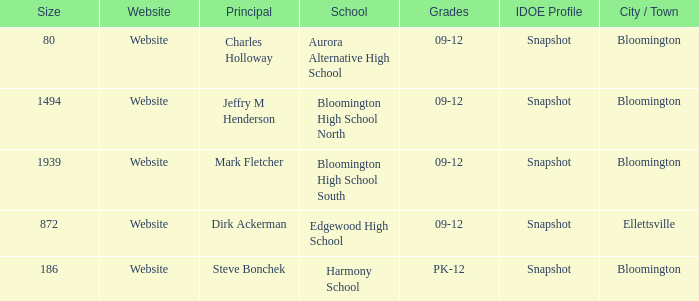Write the full table. {'header': ['Size', 'Website', 'Principal', 'School', 'Grades', 'IDOE Profile', 'City / Town'], 'rows': [['80', 'Website', 'Charles Holloway', 'Aurora Alternative High School', '09-12', 'Snapshot', 'Bloomington'], ['1494', 'Website', 'Jeffry M Henderson', 'Bloomington High School North', '09-12', 'Snapshot', 'Bloomington'], ['1939', 'Website', 'Mark Fletcher', 'Bloomington High School South', '09-12', 'Snapshot', 'Bloomington'], ['872', 'Website', 'Dirk Ackerman', 'Edgewood High School', '09-12', 'Snapshot', 'Ellettsville'], ['186', 'Website', 'Steve Bonchek', 'Harmony School', 'PK-12', 'Snapshot', 'Bloomington']]} Who's the principal of Edgewood High School?/ Dirk Ackerman. 